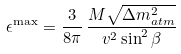Convert formula to latex. <formula><loc_0><loc_0><loc_500><loc_500>\epsilon ^ { \max } = \frac { 3 } { 8 \pi } \, \frac { M \sqrt { \Delta m _ { a t m } ^ { 2 } } } { v ^ { 2 } \sin ^ { 2 } \beta }</formula> 